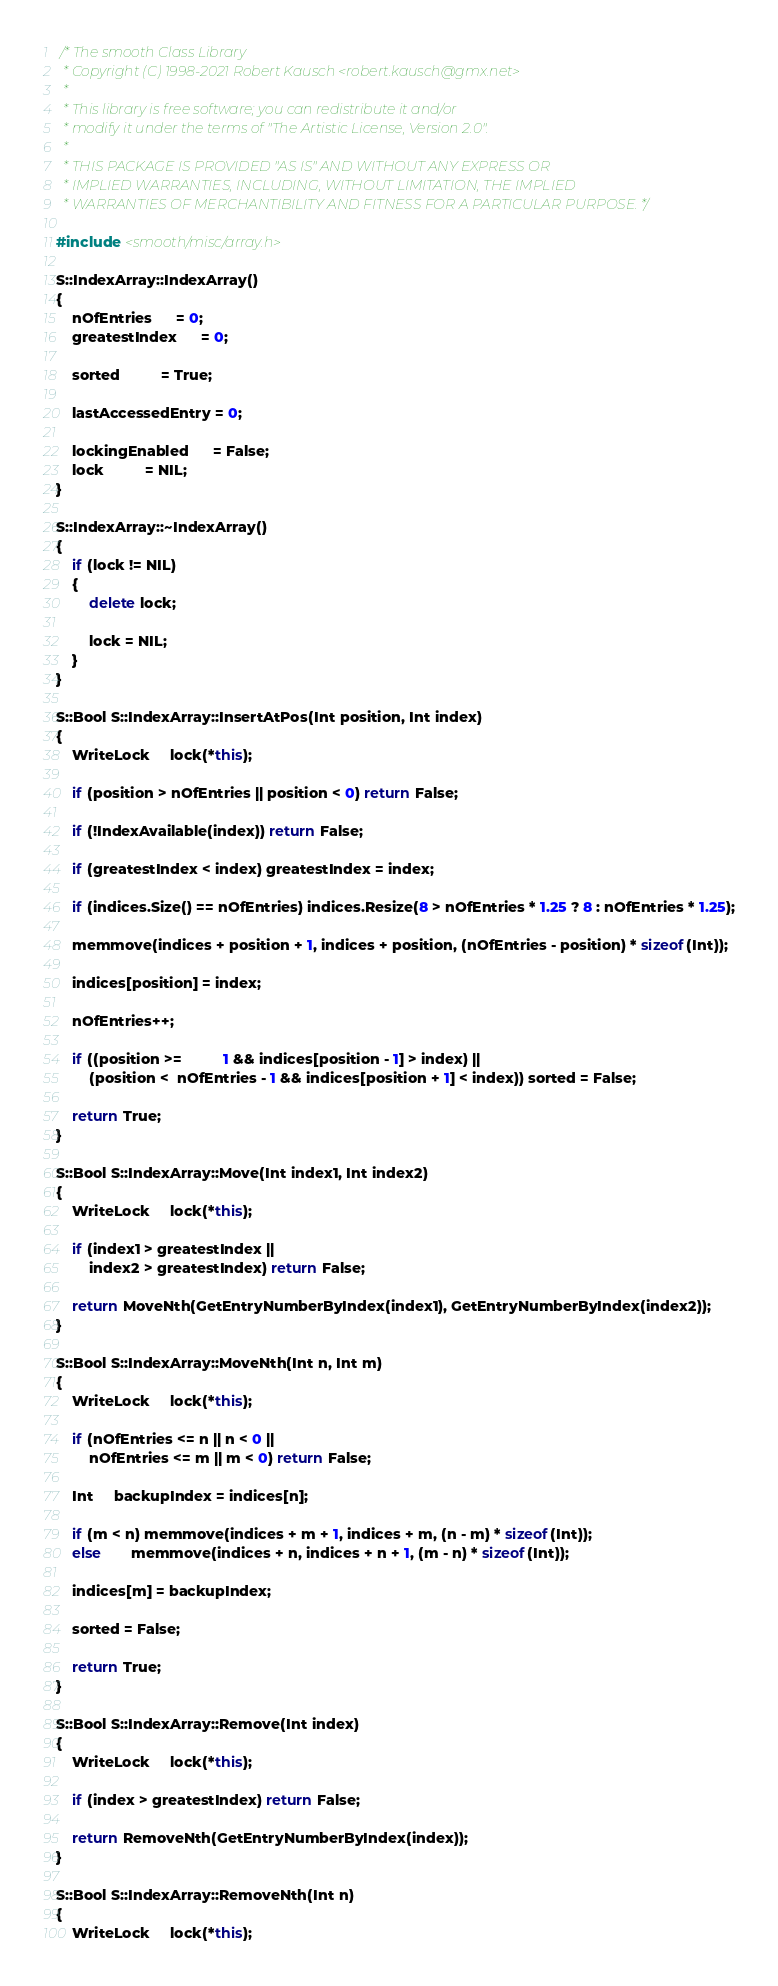Convert code to text. <code><loc_0><loc_0><loc_500><loc_500><_C++_> /* The smooth Class Library
  * Copyright (C) 1998-2021 Robert Kausch <robert.kausch@gmx.net>
  *
  * This library is free software; you can redistribute it and/or
  * modify it under the terms of "The Artistic License, Version 2.0".
  *
  * THIS PACKAGE IS PROVIDED "AS IS" AND WITHOUT ANY EXPRESS OR
  * IMPLIED WARRANTIES, INCLUDING, WITHOUT LIMITATION, THE IMPLIED
  * WARRANTIES OF MERCHANTIBILITY AND FITNESS FOR A PARTICULAR PURPOSE. */

#include <smooth/misc/array.h>

S::IndexArray::IndexArray()
{
	nOfEntries	  = 0;
	greatestIndex	  = 0;

	sorted		  = True;

	lastAccessedEntry = 0;

	lockingEnabled	  = False;
	lock		  = NIL;
}

S::IndexArray::~IndexArray()
{
	if (lock != NIL)
	{
		delete lock;

		lock = NIL;
	}
}

S::Bool S::IndexArray::InsertAtPos(Int position, Int index)
{
	WriteLock	 lock(*this);

	if (position > nOfEntries || position < 0) return False;

	if (!IndexAvailable(index)) return False;

	if (greatestIndex < index) greatestIndex = index;

	if (indices.Size() == nOfEntries) indices.Resize(8 > nOfEntries * 1.25 ? 8 : nOfEntries * 1.25);

	memmove(indices + position + 1, indices + position, (nOfEntries - position) * sizeof(Int));

	indices[position] = index;

	nOfEntries++;

	if ((position >=	      1 && indices[position - 1] > index) ||
	    (position <  nOfEntries - 1 && indices[position + 1] < index)) sorted = False;

	return True;
}

S::Bool S::IndexArray::Move(Int index1, Int index2)
{
	WriteLock	 lock(*this);

	if (index1 > greatestIndex ||
	    index2 > greatestIndex) return False;

	return MoveNth(GetEntryNumberByIndex(index1), GetEntryNumberByIndex(index2));
}

S::Bool S::IndexArray::MoveNth(Int n, Int m)
{
	WriteLock	 lock(*this);

	if (nOfEntries <= n || n < 0 ||
	    nOfEntries <= m || m < 0) return False;

	Int	 backupIndex = indices[n];

	if (m < n) memmove(indices + m + 1, indices + m, (n - m) * sizeof(Int));
	else	   memmove(indices + n, indices + n + 1, (m - n) * sizeof(Int));

	indices[m] = backupIndex;

	sorted = False;

	return True;
}

S::Bool S::IndexArray::Remove(Int index)
{
	WriteLock	 lock(*this);

	if (index > greatestIndex) return False;

	return RemoveNth(GetEntryNumberByIndex(index));
}

S::Bool S::IndexArray::RemoveNth(Int n)
{
	WriteLock	 lock(*this);
</code> 